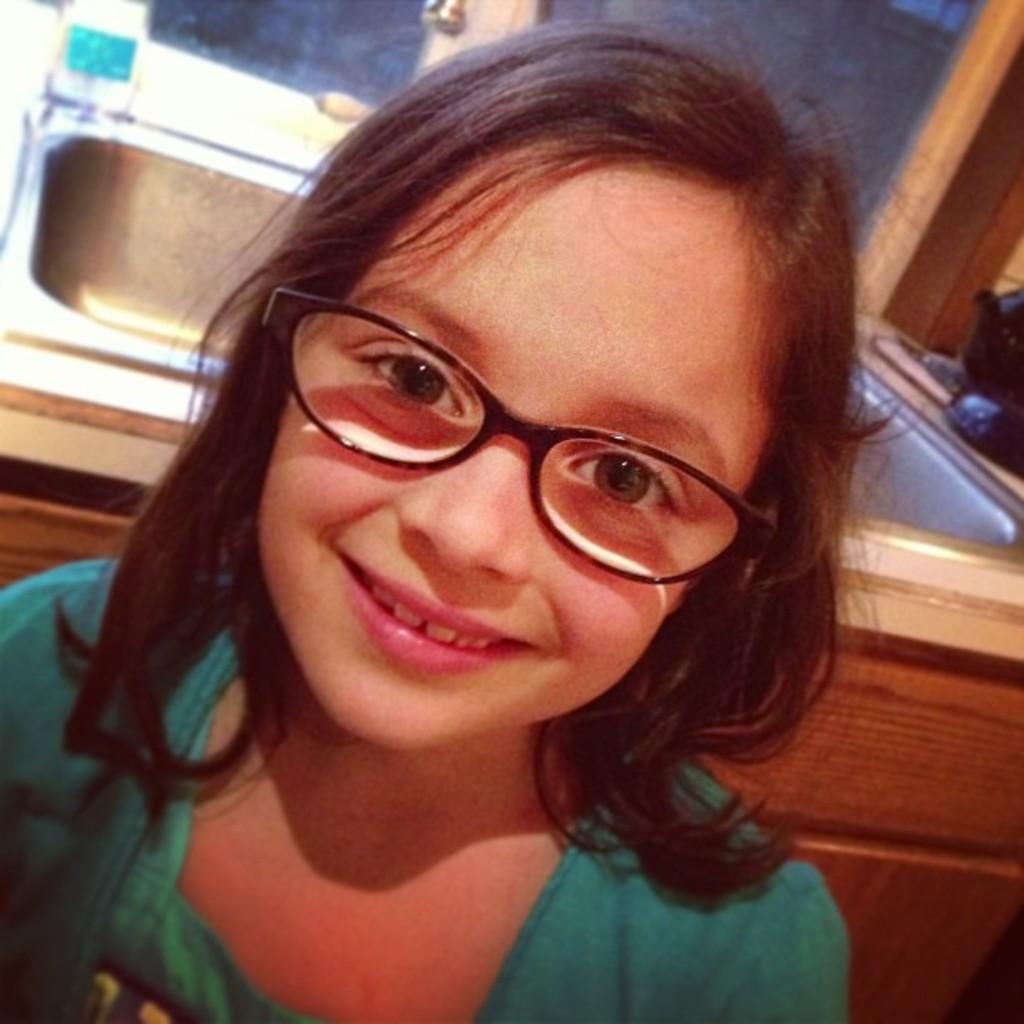What is the main subject of the image? There is a child in the image. Can you describe the child's appearance? The child is wearing spectacles. What can be seen in the background of the image? There is a sink visible in the image. How many snakes are slithering around the child in the image? There are no snakes present in the image. What type of door can be seen in the image? There is no door visible in the image. 